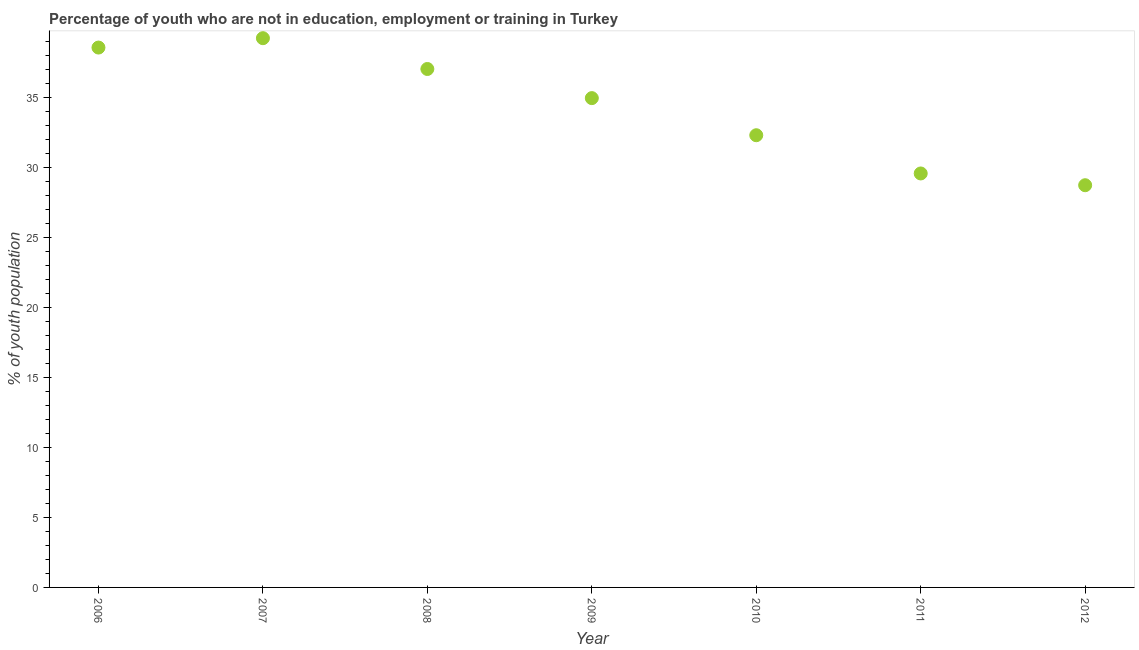What is the unemployed youth population in 2006?
Your answer should be very brief. 38.55. Across all years, what is the maximum unemployed youth population?
Your response must be concise. 39.22. Across all years, what is the minimum unemployed youth population?
Provide a short and direct response. 28.72. In which year was the unemployed youth population minimum?
Your answer should be compact. 2012. What is the sum of the unemployed youth population?
Keep it short and to the point. 240.3. What is the difference between the unemployed youth population in 2008 and 2012?
Give a very brief answer. 8.3. What is the average unemployed youth population per year?
Your response must be concise. 34.33. What is the median unemployed youth population?
Your response must be concise. 34.94. In how many years, is the unemployed youth population greater than 15 %?
Your answer should be compact. 7. Do a majority of the years between 2007 and 2010 (inclusive) have unemployed youth population greater than 7 %?
Keep it short and to the point. Yes. What is the ratio of the unemployed youth population in 2006 to that in 2009?
Your answer should be very brief. 1.1. Is the difference between the unemployed youth population in 2007 and 2011 greater than the difference between any two years?
Your answer should be compact. No. What is the difference between the highest and the second highest unemployed youth population?
Provide a short and direct response. 0.67. Is the sum of the unemployed youth population in 2007 and 2011 greater than the maximum unemployed youth population across all years?
Offer a terse response. Yes. What is the difference between the highest and the lowest unemployed youth population?
Keep it short and to the point. 10.5. Does the unemployed youth population monotonically increase over the years?
Your response must be concise. No. How many dotlines are there?
Keep it short and to the point. 1. What is the difference between two consecutive major ticks on the Y-axis?
Ensure brevity in your answer.  5. Are the values on the major ticks of Y-axis written in scientific E-notation?
Ensure brevity in your answer.  No. Does the graph contain grids?
Give a very brief answer. No. What is the title of the graph?
Offer a terse response. Percentage of youth who are not in education, employment or training in Turkey. What is the label or title of the Y-axis?
Offer a terse response. % of youth population. What is the % of youth population in 2006?
Provide a succinct answer. 38.55. What is the % of youth population in 2007?
Offer a terse response. 39.22. What is the % of youth population in 2008?
Your answer should be very brief. 37.02. What is the % of youth population in 2009?
Provide a succinct answer. 34.94. What is the % of youth population in 2010?
Ensure brevity in your answer.  32.29. What is the % of youth population in 2011?
Your answer should be very brief. 29.56. What is the % of youth population in 2012?
Ensure brevity in your answer.  28.72. What is the difference between the % of youth population in 2006 and 2007?
Your answer should be very brief. -0.67. What is the difference between the % of youth population in 2006 and 2008?
Provide a succinct answer. 1.53. What is the difference between the % of youth population in 2006 and 2009?
Make the answer very short. 3.61. What is the difference between the % of youth population in 2006 and 2010?
Your answer should be very brief. 6.26. What is the difference between the % of youth population in 2006 and 2011?
Offer a very short reply. 8.99. What is the difference between the % of youth population in 2006 and 2012?
Your answer should be very brief. 9.83. What is the difference between the % of youth population in 2007 and 2008?
Provide a short and direct response. 2.2. What is the difference between the % of youth population in 2007 and 2009?
Ensure brevity in your answer.  4.28. What is the difference between the % of youth population in 2007 and 2010?
Provide a succinct answer. 6.93. What is the difference between the % of youth population in 2007 and 2011?
Give a very brief answer. 9.66. What is the difference between the % of youth population in 2007 and 2012?
Make the answer very short. 10.5. What is the difference between the % of youth population in 2008 and 2009?
Keep it short and to the point. 2.08. What is the difference between the % of youth population in 2008 and 2010?
Offer a very short reply. 4.73. What is the difference between the % of youth population in 2008 and 2011?
Your response must be concise. 7.46. What is the difference between the % of youth population in 2009 and 2010?
Provide a succinct answer. 2.65. What is the difference between the % of youth population in 2009 and 2011?
Your answer should be compact. 5.38. What is the difference between the % of youth population in 2009 and 2012?
Keep it short and to the point. 6.22. What is the difference between the % of youth population in 2010 and 2011?
Make the answer very short. 2.73. What is the difference between the % of youth population in 2010 and 2012?
Your answer should be very brief. 3.57. What is the difference between the % of youth population in 2011 and 2012?
Offer a terse response. 0.84. What is the ratio of the % of youth population in 2006 to that in 2008?
Your answer should be very brief. 1.04. What is the ratio of the % of youth population in 2006 to that in 2009?
Provide a succinct answer. 1.1. What is the ratio of the % of youth population in 2006 to that in 2010?
Provide a succinct answer. 1.19. What is the ratio of the % of youth population in 2006 to that in 2011?
Your response must be concise. 1.3. What is the ratio of the % of youth population in 2006 to that in 2012?
Your answer should be compact. 1.34. What is the ratio of the % of youth population in 2007 to that in 2008?
Offer a very short reply. 1.06. What is the ratio of the % of youth population in 2007 to that in 2009?
Your answer should be very brief. 1.12. What is the ratio of the % of youth population in 2007 to that in 2010?
Your answer should be very brief. 1.22. What is the ratio of the % of youth population in 2007 to that in 2011?
Make the answer very short. 1.33. What is the ratio of the % of youth population in 2007 to that in 2012?
Your answer should be very brief. 1.37. What is the ratio of the % of youth population in 2008 to that in 2009?
Make the answer very short. 1.06. What is the ratio of the % of youth population in 2008 to that in 2010?
Keep it short and to the point. 1.15. What is the ratio of the % of youth population in 2008 to that in 2011?
Provide a short and direct response. 1.25. What is the ratio of the % of youth population in 2008 to that in 2012?
Provide a succinct answer. 1.29. What is the ratio of the % of youth population in 2009 to that in 2010?
Make the answer very short. 1.08. What is the ratio of the % of youth population in 2009 to that in 2011?
Your response must be concise. 1.18. What is the ratio of the % of youth population in 2009 to that in 2012?
Your answer should be very brief. 1.22. What is the ratio of the % of youth population in 2010 to that in 2011?
Keep it short and to the point. 1.09. What is the ratio of the % of youth population in 2010 to that in 2012?
Your answer should be very brief. 1.12. 